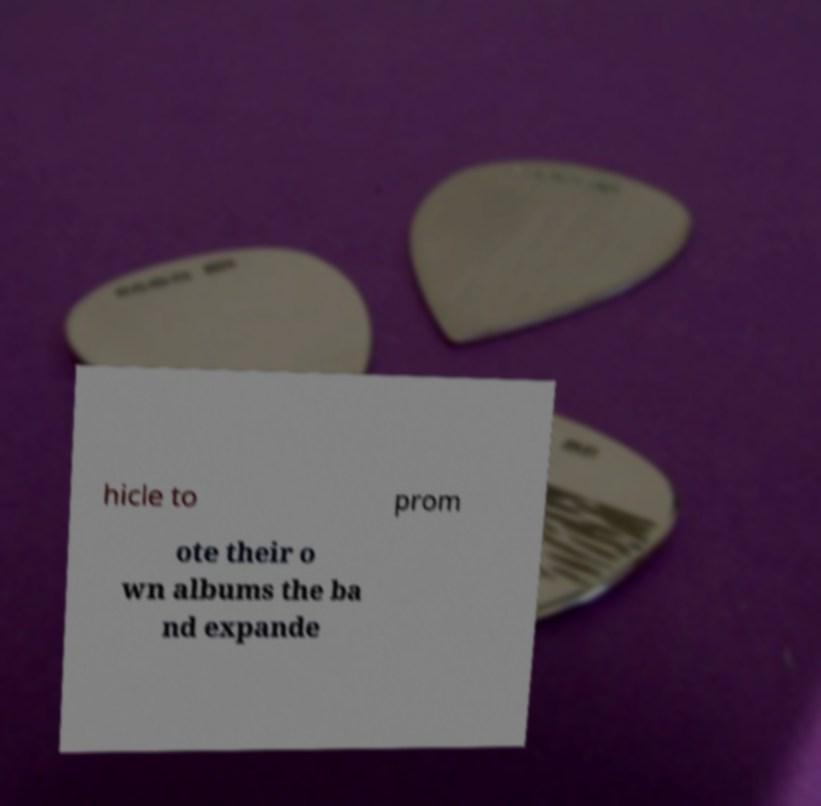Can you read and provide the text displayed in the image?This photo seems to have some interesting text. Can you extract and type it out for me? hicle to prom ote their o wn albums the ba nd expande 